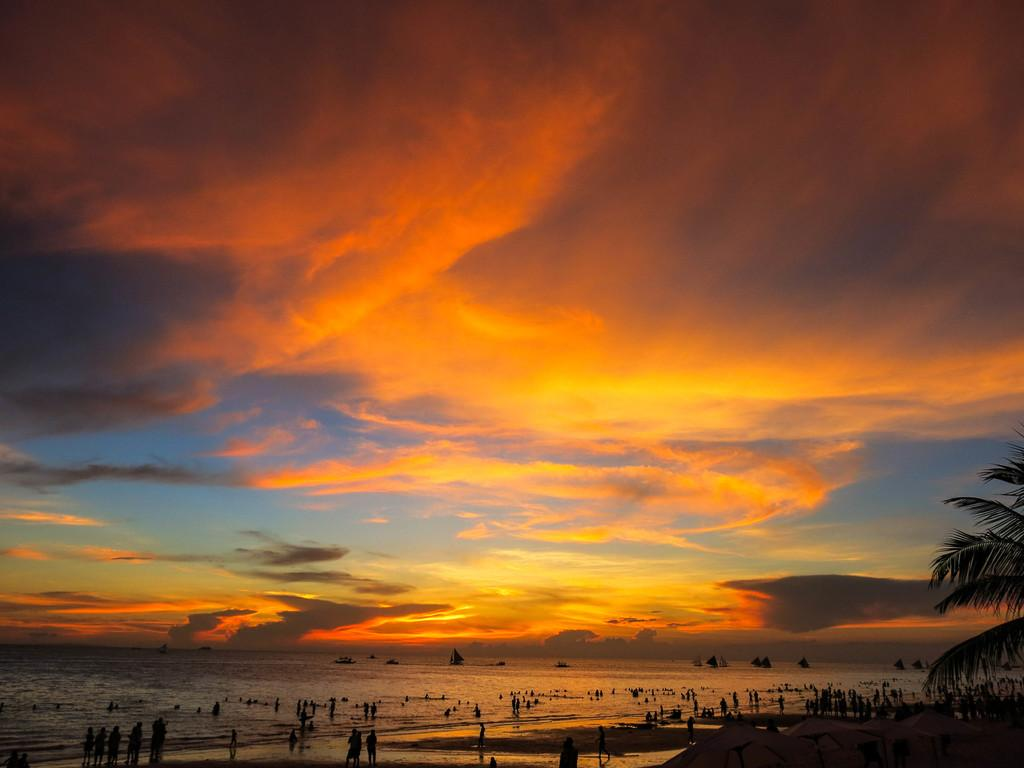What are the people in the image doing? The people in the image are standing on the water. What else can be seen in the image besides the people? There are boats visible in the image. What type of vegetation is present in the image? There is a tree at the side of the image. What is visible in the background of the image? The sky is visible in the image. Can you tell me what the friend of the tree is doing in the image? There is no friend of the tree present in the image, as trees do not have friends. 